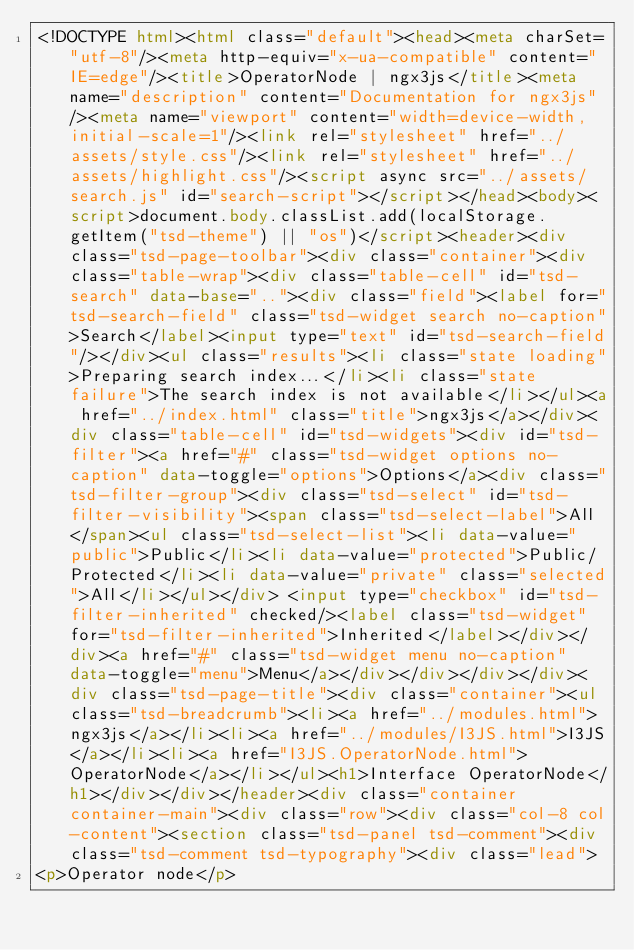<code> <loc_0><loc_0><loc_500><loc_500><_HTML_><!DOCTYPE html><html class="default"><head><meta charSet="utf-8"/><meta http-equiv="x-ua-compatible" content="IE=edge"/><title>OperatorNode | ngx3js</title><meta name="description" content="Documentation for ngx3js"/><meta name="viewport" content="width=device-width, initial-scale=1"/><link rel="stylesheet" href="../assets/style.css"/><link rel="stylesheet" href="../assets/highlight.css"/><script async src="../assets/search.js" id="search-script"></script></head><body><script>document.body.classList.add(localStorage.getItem("tsd-theme") || "os")</script><header><div class="tsd-page-toolbar"><div class="container"><div class="table-wrap"><div class="table-cell" id="tsd-search" data-base=".."><div class="field"><label for="tsd-search-field" class="tsd-widget search no-caption">Search</label><input type="text" id="tsd-search-field"/></div><ul class="results"><li class="state loading">Preparing search index...</li><li class="state failure">The search index is not available</li></ul><a href="../index.html" class="title">ngx3js</a></div><div class="table-cell" id="tsd-widgets"><div id="tsd-filter"><a href="#" class="tsd-widget options no-caption" data-toggle="options">Options</a><div class="tsd-filter-group"><div class="tsd-select" id="tsd-filter-visibility"><span class="tsd-select-label">All</span><ul class="tsd-select-list"><li data-value="public">Public</li><li data-value="protected">Public/Protected</li><li data-value="private" class="selected">All</li></ul></div> <input type="checkbox" id="tsd-filter-inherited" checked/><label class="tsd-widget" for="tsd-filter-inherited">Inherited</label></div></div><a href="#" class="tsd-widget menu no-caption" data-toggle="menu">Menu</a></div></div></div></div><div class="tsd-page-title"><div class="container"><ul class="tsd-breadcrumb"><li><a href="../modules.html">ngx3js</a></li><li><a href="../modules/I3JS.html">I3JS</a></li><li><a href="I3JS.OperatorNode.html">OperatorNode</a></li></ul><h1>Interface OperatorNode</h1></div></div></header><div class="container container-main"><div class="row"><div class="col-8 col-content"><section class="tsd-panel tsd-comment"><div class="tsd-comment tsd-typography"><div class="lead">
<p>Operator node</p></code> 